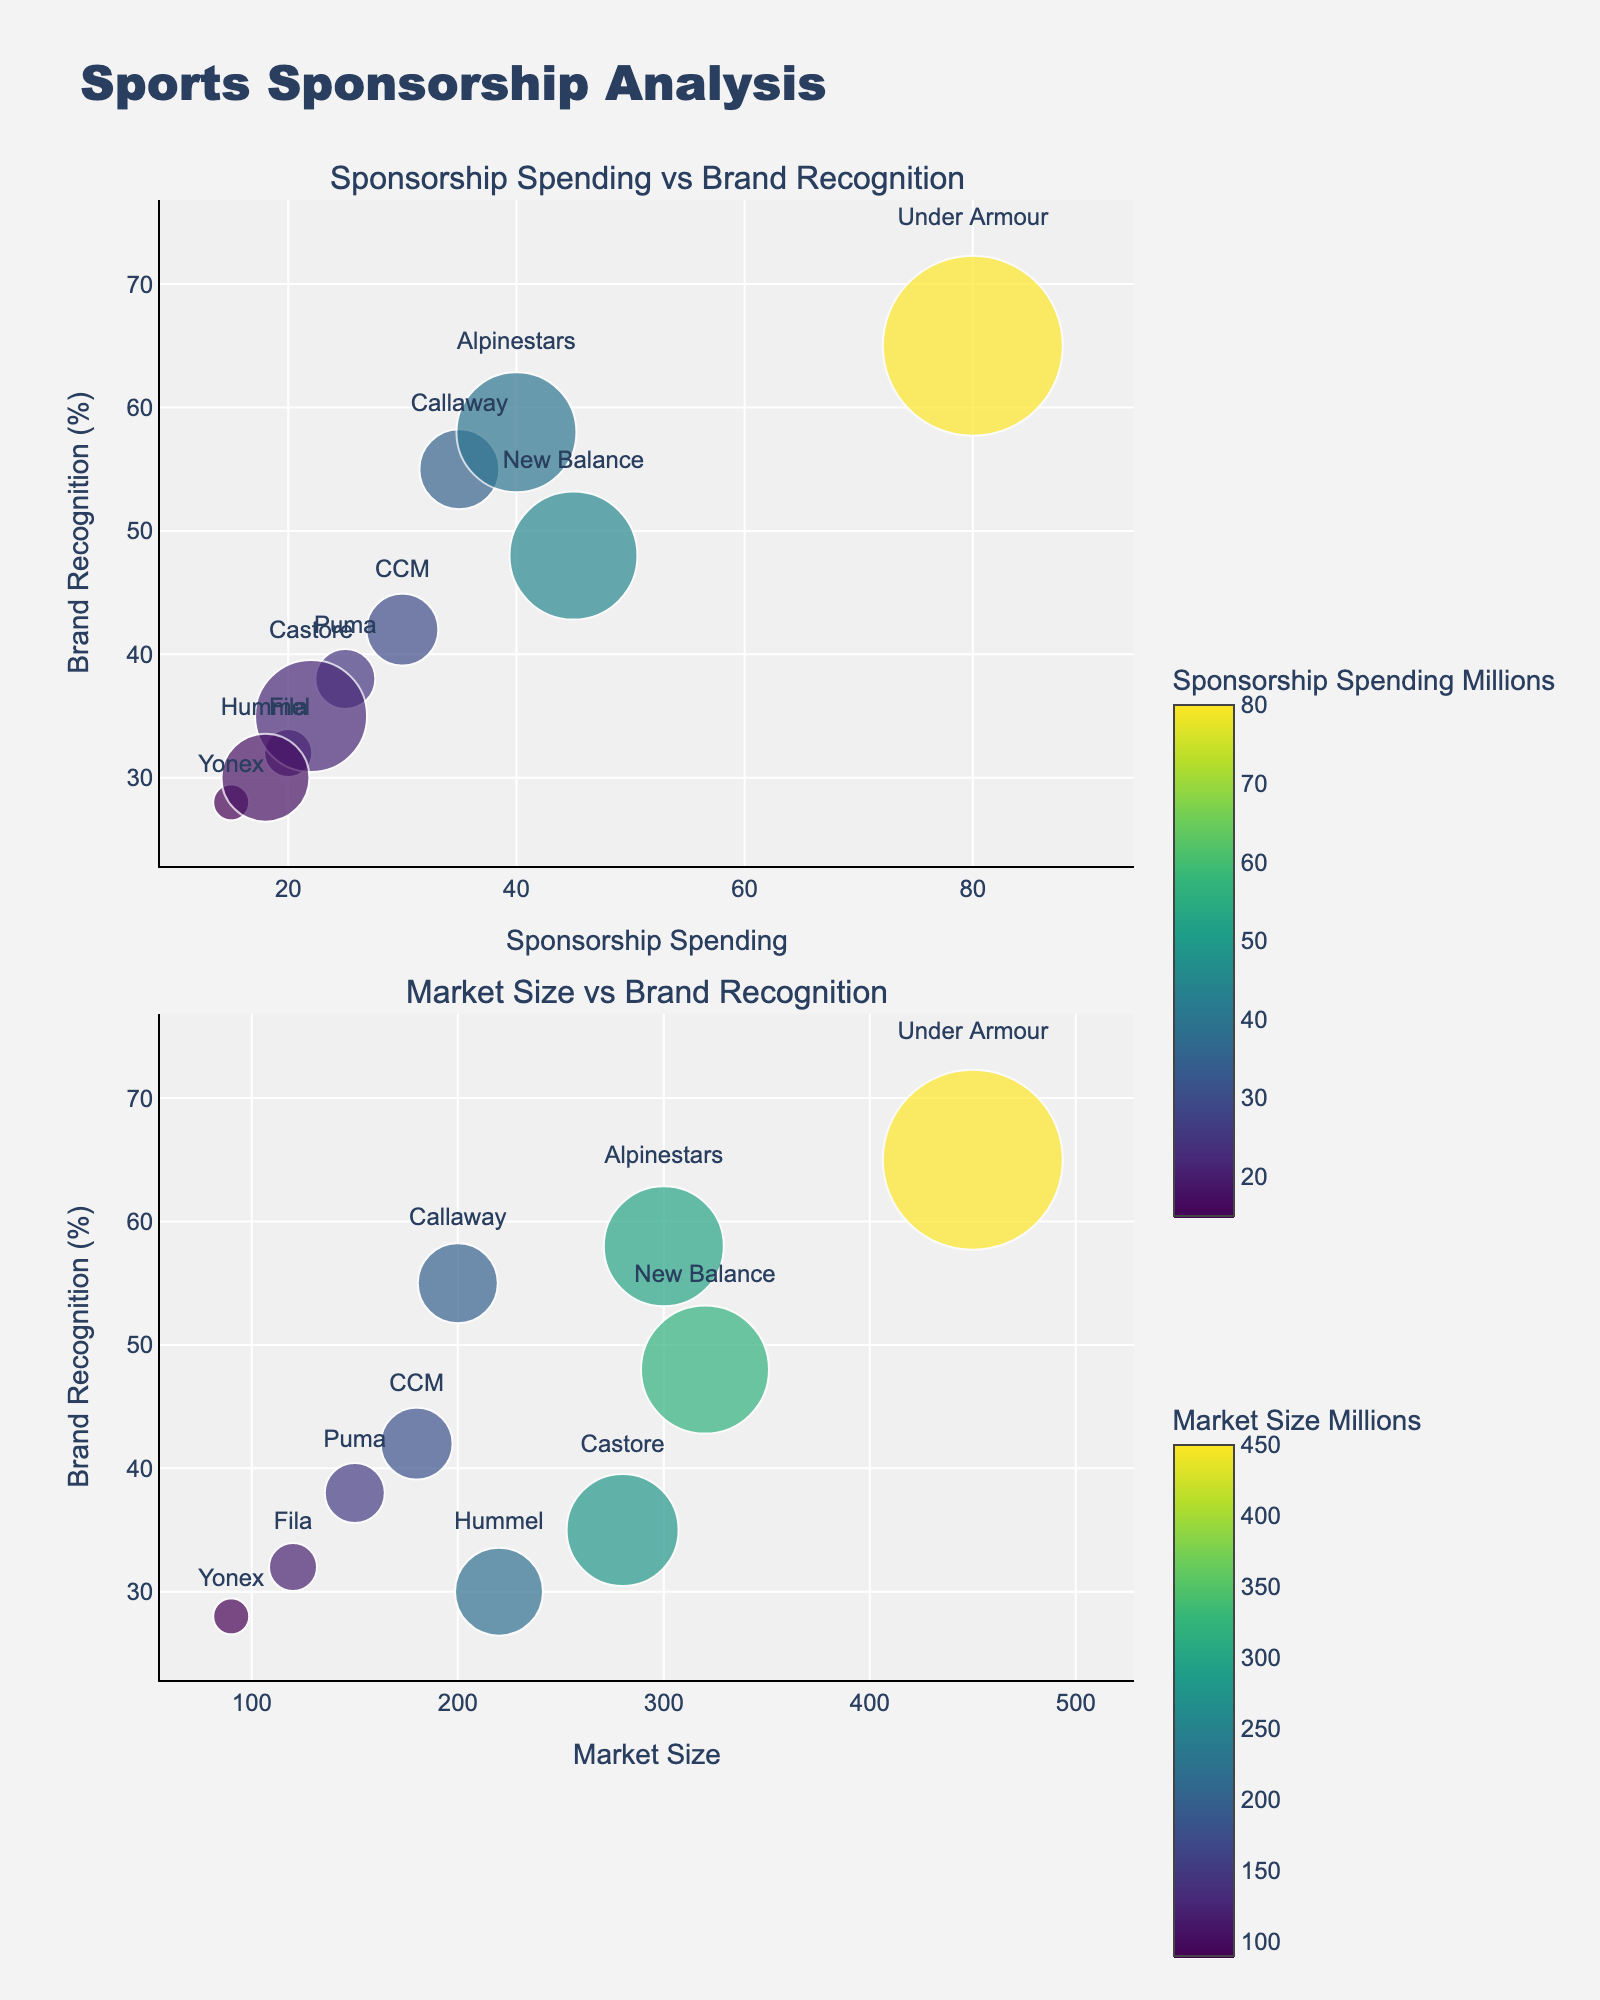What's the title of the plot? The title is positioned at the top of the figure and is usually larger in font size than other texts.
Answer: Sports Sponsorship Analysis What are the x and y axes titled in the first subplot? The x-axis title in the first subplot is located below the x-axis, and the y-axis title is to the left of the y-axis, both are labeled according to the data they represent.
Answer: Sponsorship Spending vs. Brand Recognition: x-axis is Sponsorship Spending (Millions), y-axis is Brand Recognition (%) What brand has the highest sponsorship spending in the NBA? Locate the bubble representing the NBA league in the first subplot. The highest sponsorship spending looks for the maximum on the x-axis within the NBA data points.
Answer: Under Armour Which brand is associated with the smallest market size in the data? The size of the bubbles represents market size. Look for the smallest bubble across both subplots.
Answer: Yonex What's the relationship between sponsorship spending and brand recognition for PGA Tour? Find the PGA Tour data point in the first subplot, check its position on both the x-axis (sponsorship spending) and the y-axis (brand recognition).
Answer: Callaway spends 35 million on sponsorship and has 55% brand recognition How does Callaway's market size compare to Fila's? Compare the bubble size representing Callaway and Fila. Larger bubbles indicate larger market sizes. Refer to the provided data as necessary.
Answer: Callaway has a market size of 200 million, which is larger than Fila's 120 million Which league has the lowest brand recognition percentage? Find the lowest value on the y-axis across both subplots. Locate the league and brand associated with this value.
Answer: WTA Tour (Yonex) What is the average market size of brands with more than 40% brand recognition? Identify bubbles in both subplots with brand recognition above 40%. Sum their market sizes and divide by the number of such bubbles. Detailed steps: (Under Armour: 450 + New Balance: 320 + Callaway: 200 + Alpinestars: 300)/4 = 1270/4
Answer: 317.5 million Which brands have higher brand recognition in the Formula 1 league, Alpinestars or Puma in the MLS league? Compare the y-axis values for Alpinestars in Formula 1 and Puma in MLS in the first subplot.
Answer: Alpinestars (58%) has higher brand recognition than Puma (38%) How does brand recognition for Castore compare between Bundusliga and Premier League leagues? Compare the y-axis position for Castore in Premier League to Hummel in Bundesliga in the first subplot. Check their brand recognition percentages.
Answer: Castore in Premier League has a recognition of 35%, while Hummel in Bundesliga has 30% 